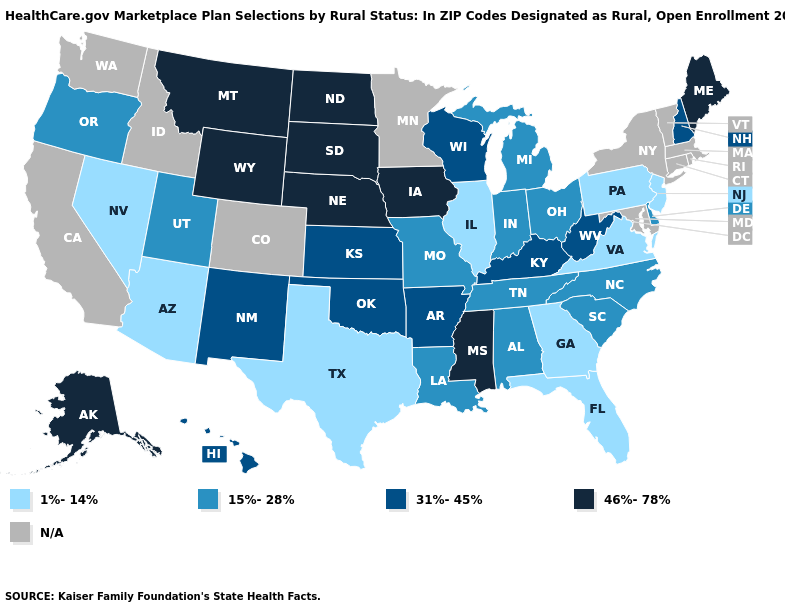Which states have the lowest value in the USA?
Short answer required. Arizona, Florida, Georgia, Illinois, Nevada, New Jersey, Pennsylvania, Texas, Virginia. Name the states that have a value in the range N/A?
Keep it brief. California, Colorado, Connecticut, Idaho, Maryland, Massachusetts, Minnesota, New York, Rhode Island, Vermont, Washington. What is the highest value in the USA?
Write a very short answer. 46%-78%. What is the value of Illinois?
Keep it brief. 1%-14%. What is the value of Virginia?
Answer briefly. 1%-14%. What is the highest value in the USA?
Answer briefly. 46%-78%. How many symbols are there in the legend?
Keep it brief. 5. Name the states that have a value in the range N/A?
Write a very short answer. California, Colorado, Connecticut, Idaho, Maryland, Massachusetts, Minnesota, New York, Rhode Island, Vermont, Washington. Name the states that have a value in the range N/A?
Be succinct. California, Colorado, Connecticut, Idaho, Maryland, Massachusetts, Minnesota, New York, Rhode Island, Vermont, Washington. Which states have the highest value in the USA?
Keep it brief. Alaska, Iowa, Maine, Mississippi, Montana, Nebraska, North Dakota, South Dakota, Wyoming. Name the states that have a value in the range 1%-14%?
Write a very short answer. Arizona, Florida, Georgia, Illinois, Nevada, New Jersey, Pennsylvania, Texas, Virginia. Which states have the lowest value in the USA?
Short answer required. Arizona, Florida, Georgia, Illinois, Nevada, New Jersey, Pennsylvania, Texas, Virginia. Name the states that have a value in the range 1%-14%?
Quick response, please. Arizona, Florida, Georgia, Illinois, Nevada, New Jersey, Pennsylvania, Texas, Virginia. What is the value of Texas?
Keep it brief. 1%-14%. 